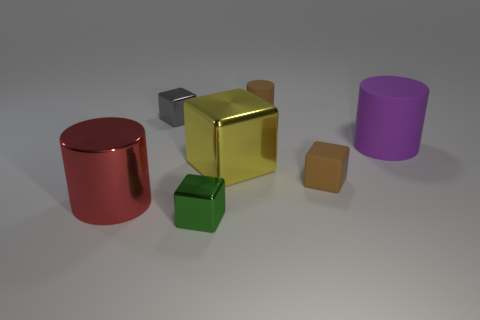There is a matte cylinder behind the tiny gray cube; does it have the same color as the matte block?
Your answer should be very brief. Yes. The big metallic object on the right side of the cylinder in front of the purple object is what shape?
Keep it short and to the point. Cube. Is there a yellow cube that has the same size as the green metallic cube?
Give a very brief answer. No. Are there fewer tiny gray objects than blocks?
Your response must be concise. Yes. There is a small brown matte thing behind the tiny metal cube that is behind the large cylinder that is behind the large block; what shape is it?
Give a very brief answer. Cylinder. What number of objects are either brown rubber things that are behind the big purple rubber thing or objects on the left side of the green cube?
Ensure brevity in your answer.  3. There is a tiny green block; are there any cylinders to the right of it?
Your response must be concise. Yes. How many things are brown cylinders that are behind the red object or yellow shiny blocks?
Your answer should be compact. 2. How many brown objects are either small things or small shiny things?
Make the answer very short. 2. What number of other objects are the same color as the tiny cylinder?
Make the answer very short. 1. 